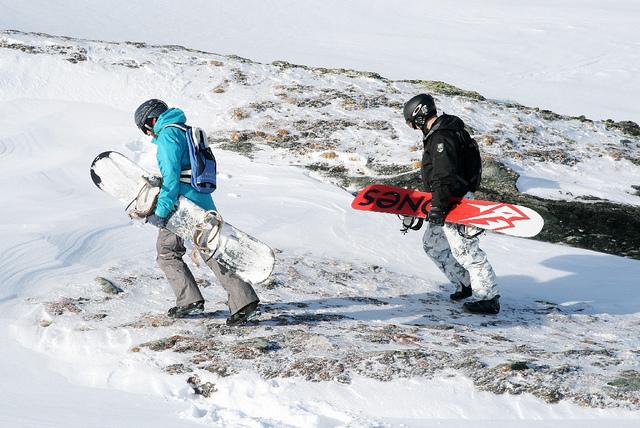Is it cold in the image?
Concise answer only. Yes. What time of year is it?
Quick response, please. Winter. Why are they carrying their snowboards?
Give a very brief answer. Getting ready. 